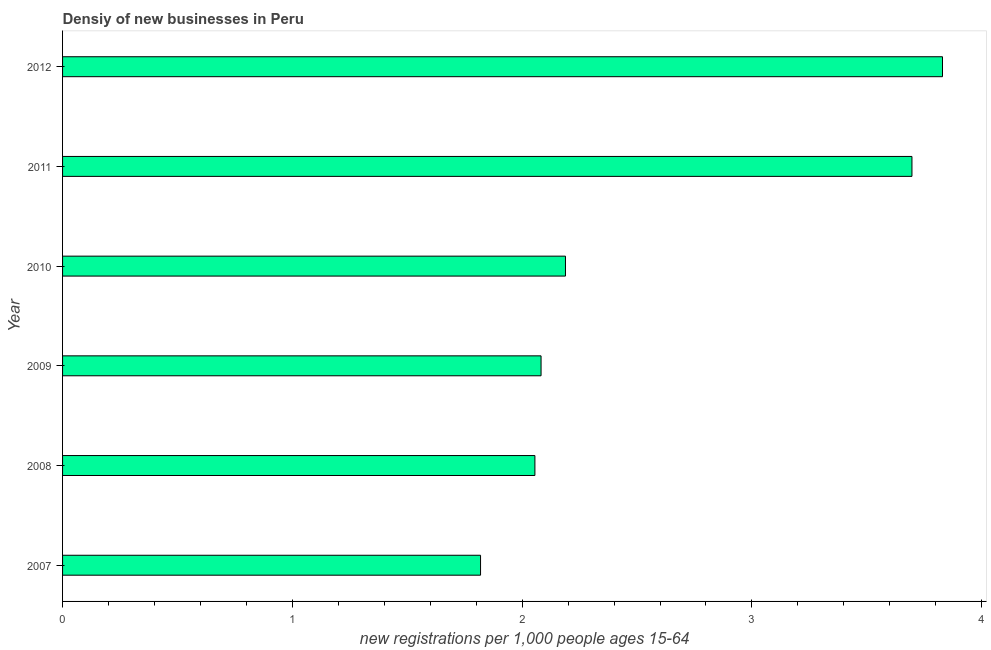Does the graph contain any zero values?
Your response must be concise. No. Does the graph contain grids?
Offer a terse response. No. What is the title of the graph?
Provide a short and direct response. Densiy of new businesses in Peru. What is the label or title of the X-axis?
Offer a very short reply. New registrations per 1,0 people ages 15-64. What is the density of new business in 2011?
Offer a terse response. 3.7. Across all years, what is the maximum density of new business?
Your answer should be very brief. 3.83. Across all years, what is the minimum density of new business?
Your answer should be compact. 1.82. In which year was the density of new business maximum?
Your answer should be very brief. 2012. What is the sum of the density of new business?
Provide a succinct answer. 15.67. What is the difference between the density of new business in 2007 and 2008?
Your answer should be very brief. -0.24. What is the average density of new business per year?
Provide a succinct answer. 2.61. What is the median density of new business?
Offer a terse response. 2.14. In how many years, is the density of new business greater than 0.8 ?
Offer a very short reply. 6. Do a majority of the years between 2009 and 2007 (inclusive) have density of new business greater than 3.6 ?
Keep it short and to the point. Yes. What is the ratio of the density of new business in 2009 to that in 2010?
Make the answer very short. 0.95. What is the difference between the highest and the second highest density of new business?
Keep it short and to the point. 0.13. Is the sum of the density of new business in 2010 and 2012 greater than the maximum density of new business across all years?
Keep it short and to the point. Yes. What is the difference between the highest and the lowest density of new business?
Offer a very short reply. 2.01. In how many years, is the density of new business greater than the average density of new business taken over all years?
Make the answer very short. 2. How many bars are there?
Your answer should be compact. 6. Are all the bars in the graph horizontal?
Your answer should be compact. Yes. What is the difference between two consecutive major ticks on the X-axis?
Your response must be concise. 1. What is the new registrations per 1,000 people ages 15-64 of 2007?
Provide a succinct answer. 1.82. What is the new registrations per 1,000 people ages 15-64 in 2008?
Your response must be concise. 2.06. What is the new registrations per 1,000 people ages 15-64 of 2009?
Keep it short and to the point. 2.08. What is the new registrations per 1,000 people ages 15-64 of 2010?
Your answer should be compact. 2.19. What is the new registrations per 1,000 people ages 15-64 of 2011?
Make the answer very short. 3.7. What is the new registrations per 1,000 people ages 15-64 in 2012?
Keep it short and to the point. 3.83. What is the difference between the new registrations per 1,000 people ages 15-64 in 2007 and 2008?
Your answer should be very brief. -0.24. What is the difference between the new registrations per 1,000 people ages 15-64 in 2007 and 2009?
Your response must be concise. -0.26. What is the difference between the new registrations per 1,000 people ages 15-64 in 2007 and 2010?
Ensure brevity in your answer.  -0.37. What is the difference between the new registrations per 1,000 people ages 15-64 in 2007 and 2011?
Ensure brevity in your answer.  -1.88. What is the difference between the new registrations per 1,000 people ages 15-64 in 2007 and 2012?
Offer a terse response. -2.01. What is the difference between the new registrations per 1,000 people ages 15-64 in 2008 and 2009?
Provide a succinct answer. -0.03. What is the difference between the new registrations per 1,000 people ages 15-64 in 2008 and 2010?
Provide a succinct answer. -0.13. What is the difference between the new registrations per 1,000 people ages 15-64 in 2008 and 2011?
Keep it short and to the point. -1.64. What is the difference between the new registrations per 1,000 people ages 15-64 in 2008 and 2012?
Your response must be concise. -1.77. What is the difference between the new registrations per 1,000 people ages 15-64 in 2009 and 2010?
Provide a succinct answer. -0.11. What is the difference between the new registrations per 1,000 people ages 15-64 in 2009 and 2011?
Your answer should be very brief. -1.61. What is the difference between the new registrations per 1,000 people ages 15-64 in 2009 and 2012?
Give a very brief answer. -1.75. What is the difference between the new registrations per 1,000 people ages 15-64 in 2010 and 2011?
Offer a very short reply. -1.51. What is the difference between the new registrations per 1,000 people ages 15-64 in 2010 and 2012?
Provide a short and direct response. -1.64. What is the difference between the new registrations per 1,000 people ages 15-64 in 2011 and 2012?
Offer a terse response. -0.13. What is the ratio of the new registrations per 1,000 people ages 15-64 in 2007 to that in 2008?
Make the answer very short. 0.89. What is the ratio of the new registrations per 1,000 people ages 15-64 in 2007 to that in 2009?
Provide a short and direct response. 0.87. What is the ratio of the new registrations per 1,000 people ages 15-64 in 2007 to that in 2010?
Provide a succinct answer. 0.83. What is the ratio of the new registrations per 1,000 people ages 15-64 in 2007 to that in 2011?
Provide a short and direct response. 0.49. What is the ratio of the new registrations per 1,000 people ages 15-64 in 2007 to that in 2012?
Your answer should be compact. 0.47. What is the ratio of the new registrations per 1,000 people ages 15-64 in 2008 to that in 2009?
Give a very brief answer. 0.99. What is the ratio of the new registrations per 1,000 people ages 15-64 in 2008 to that in 2010?
Your answer should be compact. 0.94. What is the ratio of the new registrations per 1,000 people ages 15-64 in 2008 to that in 2011?
Give a very brief answer. 0.56. What is the ratio of the new registrations per 1,000 people ages 15-64 in 2008 to that in 2012?
Keep it short and to the point. 0.54. What is the ratio of the new registrations per 1,000 people ages 15-64 in 2009 to that in 2010?
Your answer should be compact. 0.95. What is the ratio of the new registrations per 1,000 people ages 15-64 in 2009 to that in 2011?
Keep it short and to the point. 0.56. What is the ratio of the new registrations per 1,000 people ages 15-64 in 2009 to that in 2012?
Provide a short and direct response. 0.54. What is the ratio of the new registrations per 1,000 people ages 15-64 in 2010 to that in 2011?
Ensure brevity in your answer.  0.59. What is the ratio of the new registrations per 1,000 people ages 15-64 in 2010 to that in 2012?
Give a very brief answer. 0.57. What is the ratio of the new registrations per 1,000 people ages 15-64 in 2011 to that in 2012?
Your response must be concise. 0.96. 